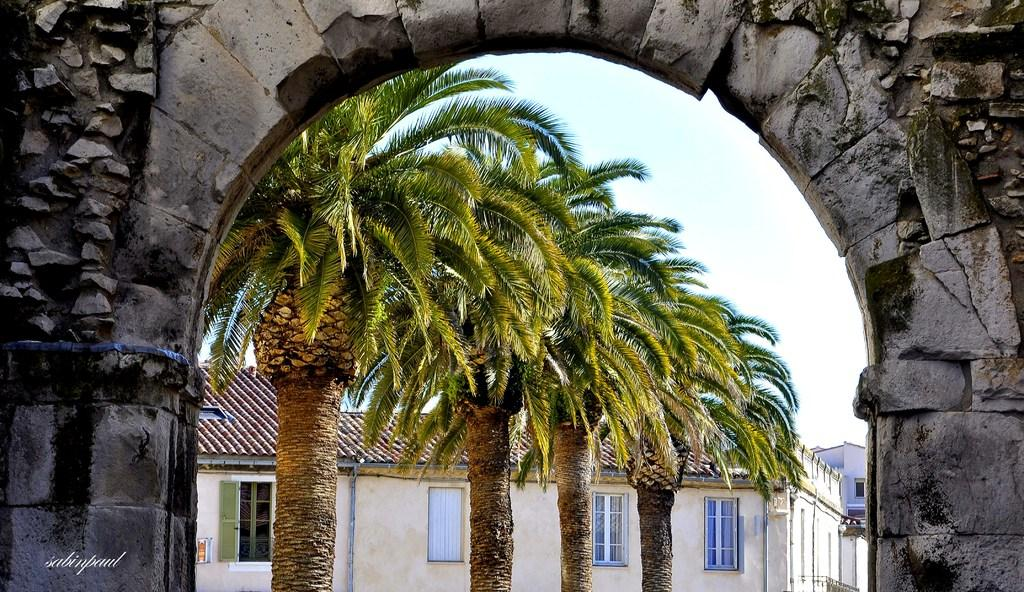What type of structure can be seen in the image? There is a stone arch in the image. What other elements are present in the image? There are trees and houses in the image. What can be seen in the background of the image? The sky is visible in the background of the image. Is there any text or marking on the image? Yes, there is a watermark on the bottom left side of the image. What type of wool is being used to create the skate in the image? There is no wool or skate present in the image; it features a stone arch, trees, houses, and the sky. 